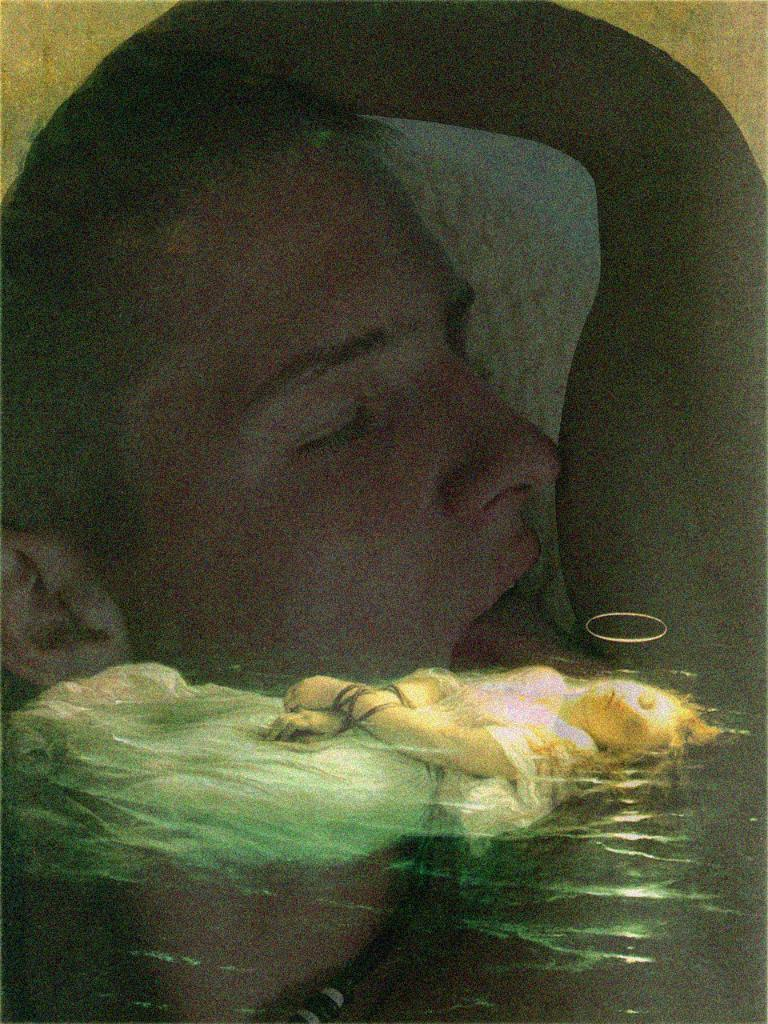Who is present in the image? There is a boy and a woman in the image. What are the boy and woman doing in the image? The boy and woman are lying in the water. What type of cable can be seen connecting the boy and woman in the image? There is no cable present in the image; the boy and woman are simply lying in the water. 